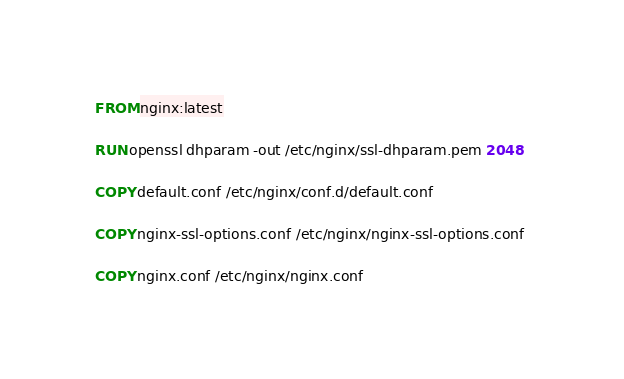Convert code to text. <code><loc_0><loc_0><loc_500><loc_500><_Dockerfile_>FROM nginx:latest

RUN openssl dhparam -out /etc/nginx/ssl-dhparam.pem 2048

COPY default.conf /etc/nginx/conf.d/default.conf

COPY nginx-ssl-options.conf /etc/nginx/nginx-ssl-options.conf 

COPY nginx.conf /etc/nginx/nginx.conf

</code> 